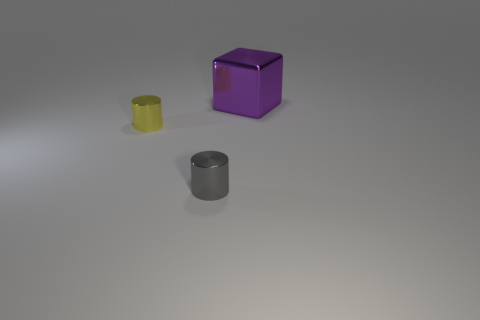Add 2 tiny brown shiny cylinders. How many objects exist? 5 Subtract 1 cylinders. How many cylinders are left? 1 Subtract all yellow cylinders. How many cylinders are left? 1 Subtract all blocks. How many objects are left? 2 Subtract all red cylinders. Subtract all yellow cubes. How many cylinders are left? 2 Subtract all tiny gray objects. Subtract all yellow objects. How many objects are left? 1 Add 1 purple cubes. How many purple cubes are left? 2 Add 1 big blue rubber cylinders. How many big blue rubber cylinders exist? 1 Subtract 0 green spheres. How many objects are left? 3 